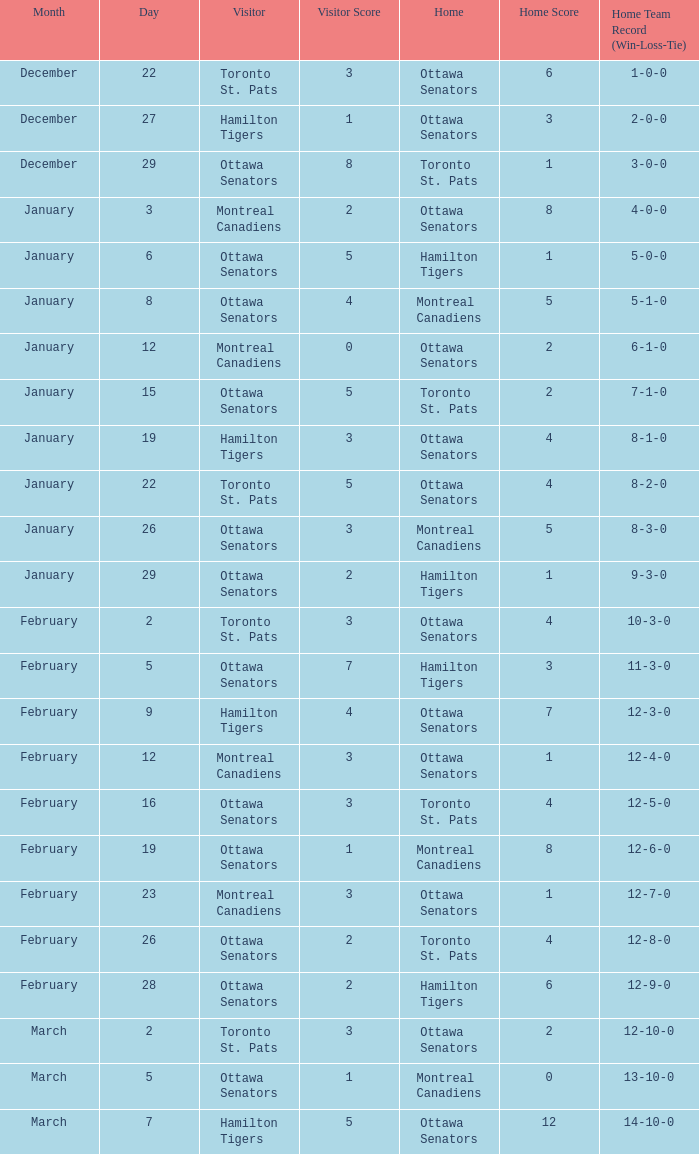I'm looking to parse the entire table for insights. Could you assist me with that? {'header': ['Month', 'Day', 'Visitor', 'Visitor Score', 'Home', 'Home Score', 'Home Team Record (Win-Loss-Tie)'], 'rows': [['December', '22', 'Toronto St. Pats', '3', 'Ottawa Senators', '6', '1-0-0'], ['December', '27', 'Hamilton Tigers', '1', 'Ottawa Senators', '3', '2-0-0'], ['December', '29', 'Ottawa Senators', '8', 'Toronto St. Pats', '1', '3-0-0'], ['January', '3', 'Montreal Canadiens', '2', 'Ottawa Senators', '8', '4-0-0'], ['January', '6', 'Ottawa Senators', '5', 'Hamilton Tigers', '1', '5-0-0'], ['January', '8', 'Ottawa Senators', '4', 'Montreal Canadiens', '5', '5-1-0'], ['January', '12', 'Montreal Canadiens', '0', 'Ottawa Senators', '2', '6-1-0'], ['January', '15', 'Ottawa Senators', '5', 'Toronto St. Pats', '2', '7-1-0'], ['January', '19', 'Hamilton Tigers', '3', 'Ottawa Senators', '4', '8-1-0'], ['January', '22', 'Toronto St. Pats', '5', 'Ottawa Senators', '4', '8-2-0'], ['January', '26', 'Ottawa Senators', '3', 'Montreal Canadiens', '5', '8-3-0'], ['January', '29', 'Ottawa Senators', '2', 'Hamilton Tigers', '1', '9-3-0'], ['February', '2', 'Toronto St. Pats', '3', 'Ottawa Senators', '4', '10-3-0'], ['February', '5', 'Ottawa Senators', '7', 'Hamilton Tigers', '3', '11-3-0'], ['February', '9', 'Hamilton Tigers', '4', 'Ottawa Senators', '7', '12-3-0'], ['February', '12', 'Montreal Canadiens', '3', 'Ottawa Senators', '1', '12-4-0'], ['February', '16', 'Ottawa Senators', '3', 'Toronto St. Pats', '4', '12-5-0'], ['February', '19', 'Ottawa Senators', '1', 'Montreal Canadiens', '8', '12-6-0'], ['February', '23', 'Montreal Canadiens', '3', 'Ottawa Senators', '1', '12-7-0'], ['February', '26', 'Ottawa Senators', '2', 'Toronto St. Pats', '4', '12-8-0'], ['February', '28', 'Ottawa Senators', '2', 'Hamilton Tigers', '6', '12-9-0'], ['March', '2', 'Toronto St. Pats', '3', 'Ottawa Senators', '2', '12-10-0'], ['March', '5', 'Ottawa Senators', '1', 'Montreal Canadiens', '0', '13-10-0'], ['March', '7', 'Hamilton Tigers', '5', 'Ottawa Senators', '12', '14-10-0']]} What is the record for the game on January 19? 8–1–0. 